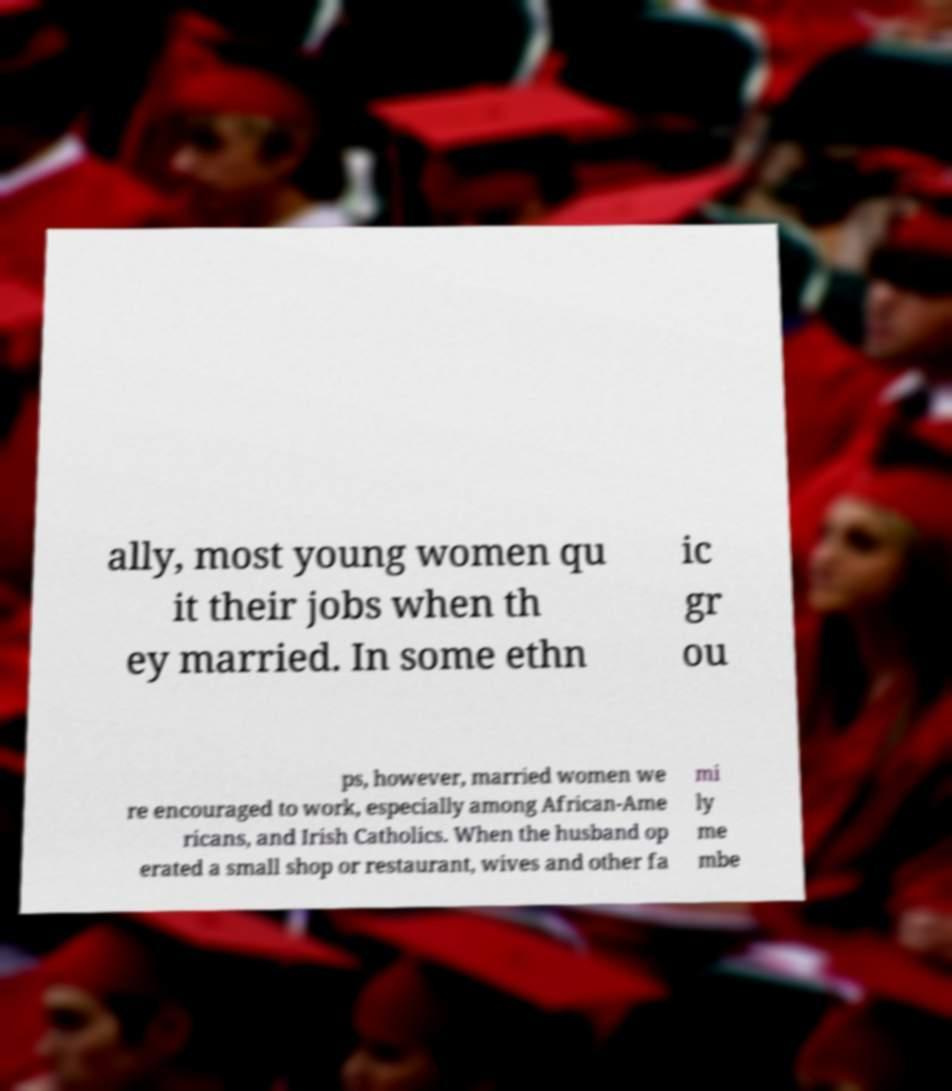Please identify and transcribe the text found in this image. ally, most young women qu it their jobs when th ey married. In some ethn ic gr ou ps, however, married women we re encouraged to work, especially among African-Ame ricans, and Irish Catholics. When the husband op erated a small shop or restaurant, wives and other fa mi ly me mbe 